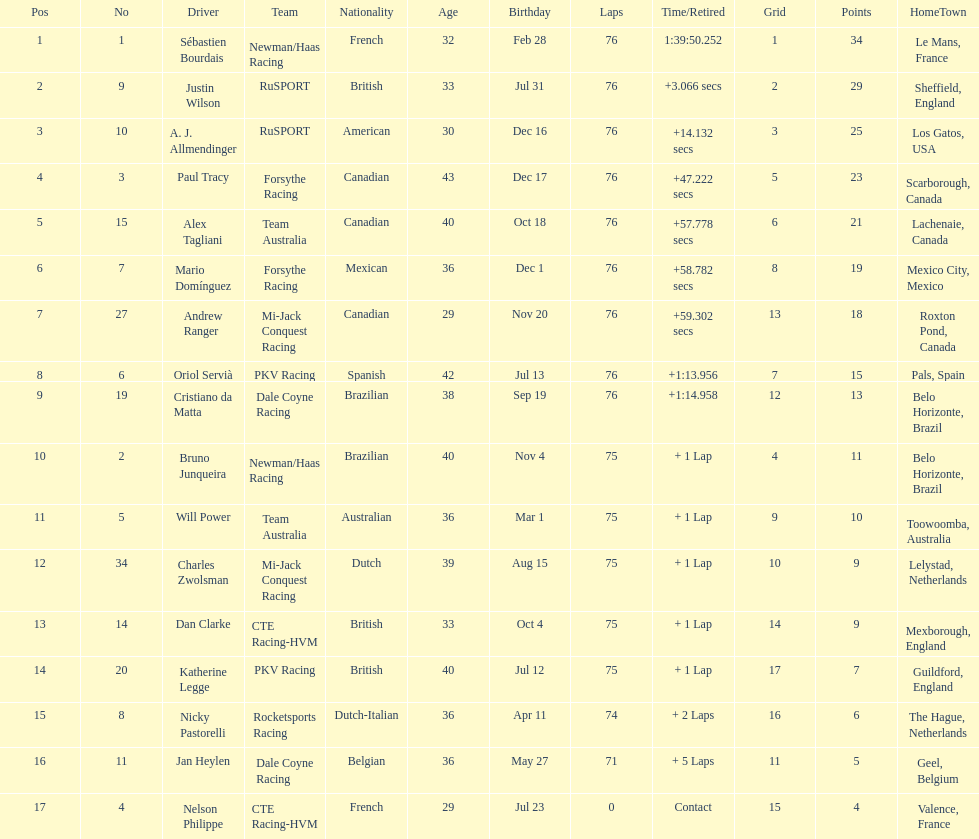Which canadian driver finished first: alex tagliani or paul tracy? Paul Tracy. 